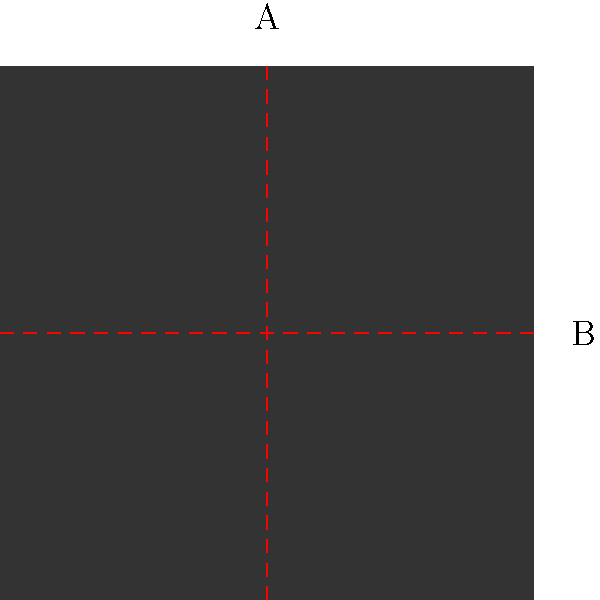Analyze the symmetry of the PlayStation logo shown above. How many axes of symmetry does it have, and what type of symmetry does it exhibit? To determine the symmetry of the PlayStation logo, let's follow these steps:

1. Observe the shape: The logo consists of a square outline with a smaller square inside, and a triangular shape at the bottom.

2. Check for vertical symmetry (axis A):
   - The logo is symmetrical about the vertical line through its center.
   - Both the outer and inner squares are bisected equally by this line.
   - The triangular shape at the bottom is also symmetrical about this line.

3. Check for horizontal symmetry (axis B):
   - The logo is not symmetrical about the horizontal line through its center.
   - The triangular shape at the bottom breaks this symmetry.

4. Check for diagonal symmetry:
   - The logo does not have diagonal symmetry due to the triangular shape.

5. Rotational symmetry:
   - The logo has 2-fold rotational symmetry (180° rotation).
   - If rotated 180°, it looks the same as the original.

6. Conclusion:
   - The logo has one axis of symmetry (vertical).
   - It exhibits reflectional symmetry about the vertical axis.
   - It also has 2-fold rotational symmetry.

Therefore, the PlayStation logo has one axis of symmetry and displays both reflectional and rotational symmetry.
Answer: One axis; reflectional and rotational symmetry 